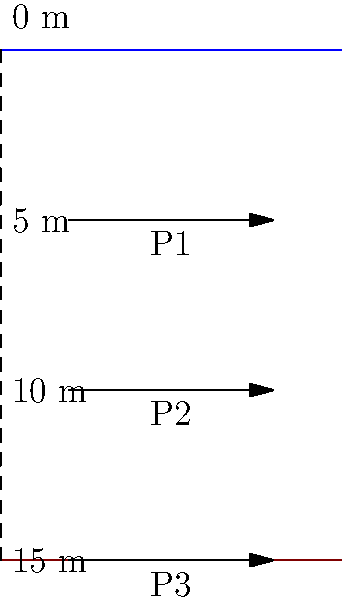During one of your adventurous expeditions with young tribe members, you decide to teach them about water pressure in the nearby lake. Using the diagram, explain how the pressure (P1, P2, P3) changes as you dive deeper into the lake. If the pressure at 5 meters depth (P1) is 49,050 Pa, what would be the pressure at 15 meters depth (P3)? Let's approach this step-by-step:

1) First, recall the formula for hydrostatic pressure:
   $$P = \rho gh$$
   Where:
   $P$ = pressure
   $\rho$ (rho) = density of water (1000 kg/m³)
   $g$ = acceleration due to gravity (9.81 m/s²)
   $h$ = depth

2) We're given that at 5 meters (P1), the pressure is 49,050 Pa. This includes atmospheric pressure, which is typically 101,325 Pa at sea level.

3) To find the pressure due to water alone at 5 meters:
   $$49,050 \text{ Pa} - 101,325 \text{ Pa} = 47,925 \text{ Pa}$$

4) Now, we can verify this using our formula:
   $$P = 1000 \text{ kg/m³} \times 9.81 \text{ m/s²} \times 5 \text{ m} = 49,050 \text{ Pa}$$

5) The pressure increases linearly with depth. At 15 meters (P3), it will be three times the water pressure at 5 meters, plus atmospheric pressure:
   $$(47,925 \text{ Pa} \times 3) + 101,325 \text{ Pa} = 245,100 \text{ Pa}$$

6) We can verify this again with our formula:
   $$P = 1000 \text{ kg/m³} \times 9.81 \text{ m/s²} \times 15 \text{ m} + 101,325 \text{ Pa} = 245,100 \text{ Pa}$$

Therefore, the pressure at 15 meters depth (P3) would be 245,100 Pa.
Answer: 245,100 Pa 